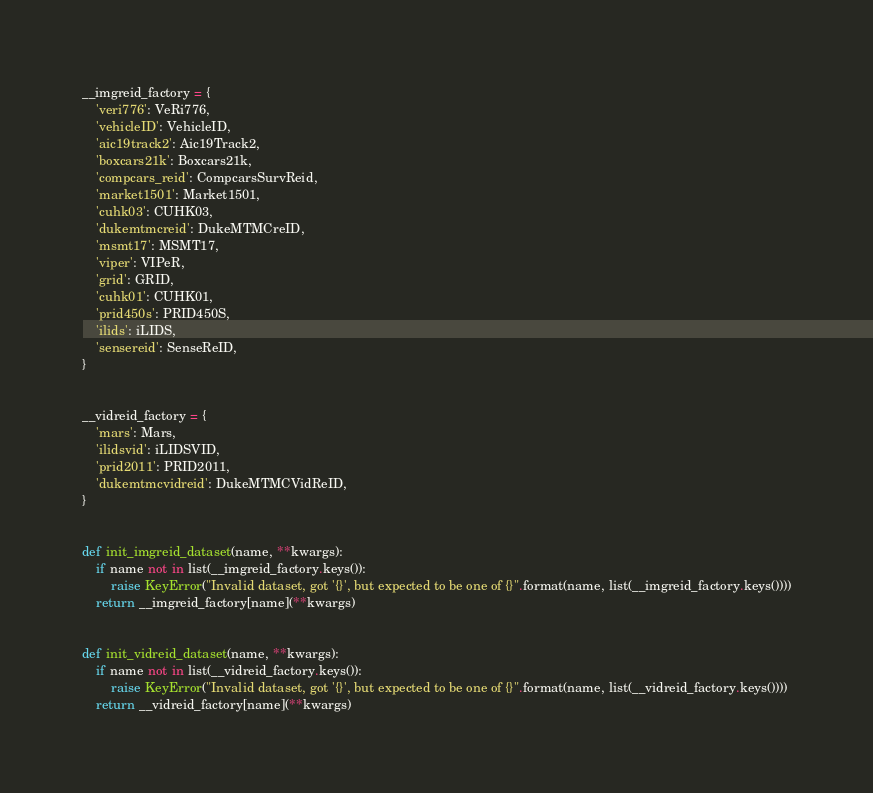Convert code to text. <code><loc_0><loc_0><loc_500><loc_500><_Python_>
__imgreid_factory = {
    'veri776': VeRi776,
    'vehicleID': VehicleID,
    'aic19track2': Aic19Track2,
    'boxcars21k': Boxcars21k,
    'compcars_reid': CompcarsSurvReid,
    'market1501': Market1501,
    'cuhk03': CUHK03,
    'dukemtmcreid': DukeMTMCreID,
    'msmt17': MSMT17,
    'viper': VIPeR,
    'grid': GRID,
    'cuhk01': CUHK01,
    'prid450s': PRID450S,
    'ilids': iLIDS,
    'sensereid': SenseReID,
}


__vidreid_factory = {
    'mars': Mars,
    'ilidsvid': iLIDSVID,
    'prid2011': PRID2011,
    'dukemtmcvidreid': DukeMTMCVidReID,
}


def init_imgreid_dataset(name, **kwargs):
    if name not in list(__imgreid_factory.keys()):
        raise KeyError("Invalid dataset, got '{}', but expected to be one of {}".format(name, list(__imgreid_factory.keys())))
    return __imgreid_factory[name](**kwargs)


def init_vidreid_dataset(name, **kwargs):
    if name not in list(__vidreid_factory.keys()):
        raise KeyError("Invalid dataset, got '{}', but expected to be one of {}".format(name, list(__vidreid_factory.keys())))
    return __vidreid_factory[name](**kwargs)
</code> 